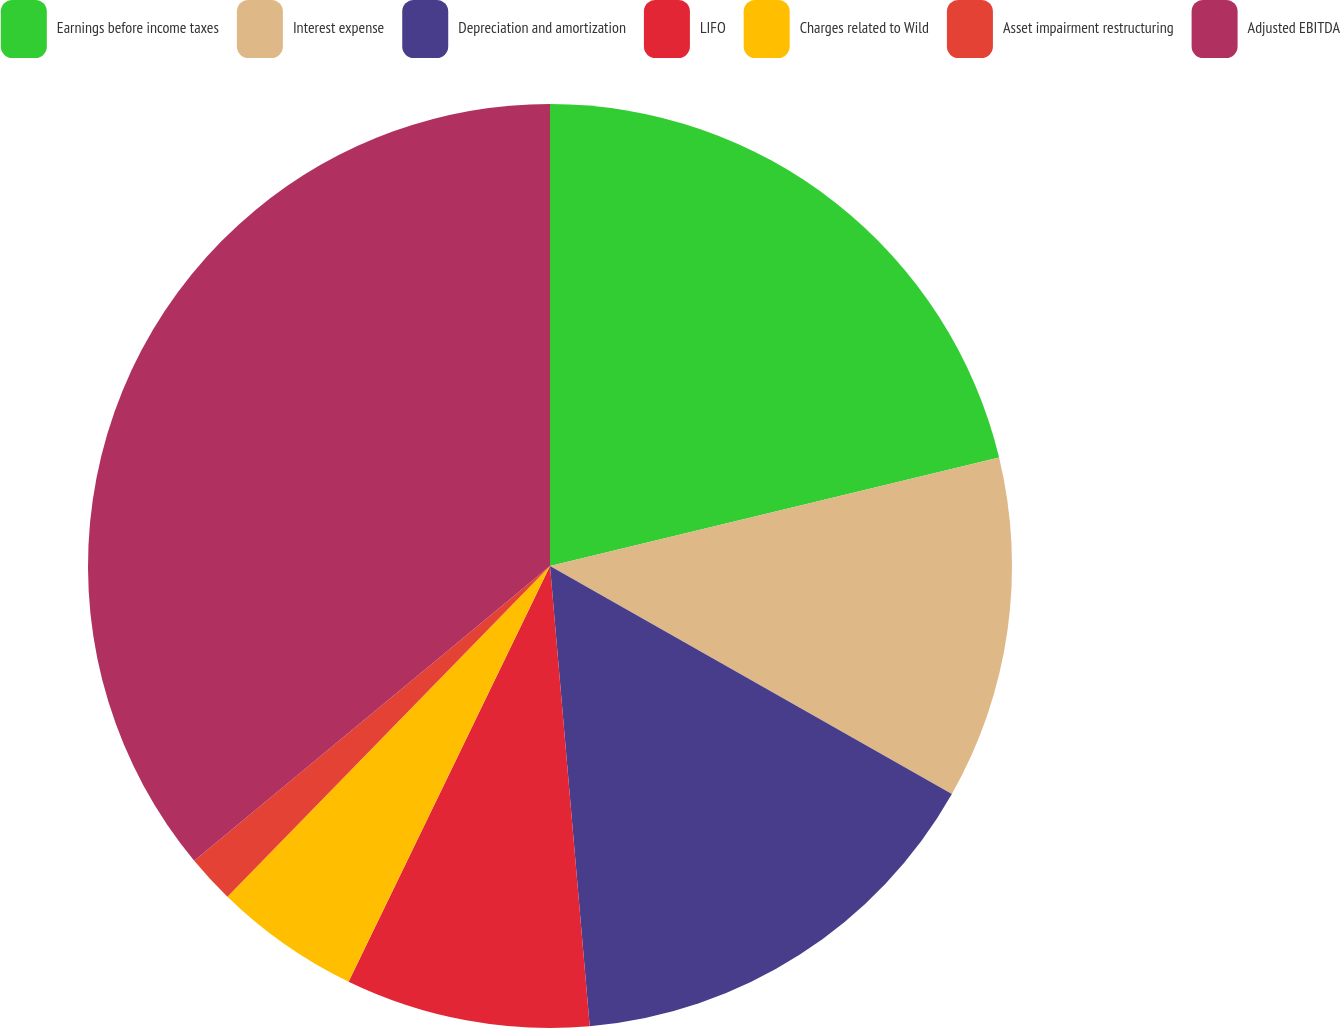Convert chart to OTSL. <chart><loc_0><loc_0><loc_500><loc_500><pie_chart><fcel>Earnings before income taxes<fcel>Interest expense<fcel>Depreciation and amortization<fcel>LIFO<fcel>Charges related to Wild<fcel>Asset impairment restructuring<fcel>Adjusted EBITDA<nl><fcel>21.23%<fcel>11.98%<fcel>15.42%<fcel>8.55%<fcel>5.12%<fcel>1.69%<fcel>36.01%<nl></chart> 